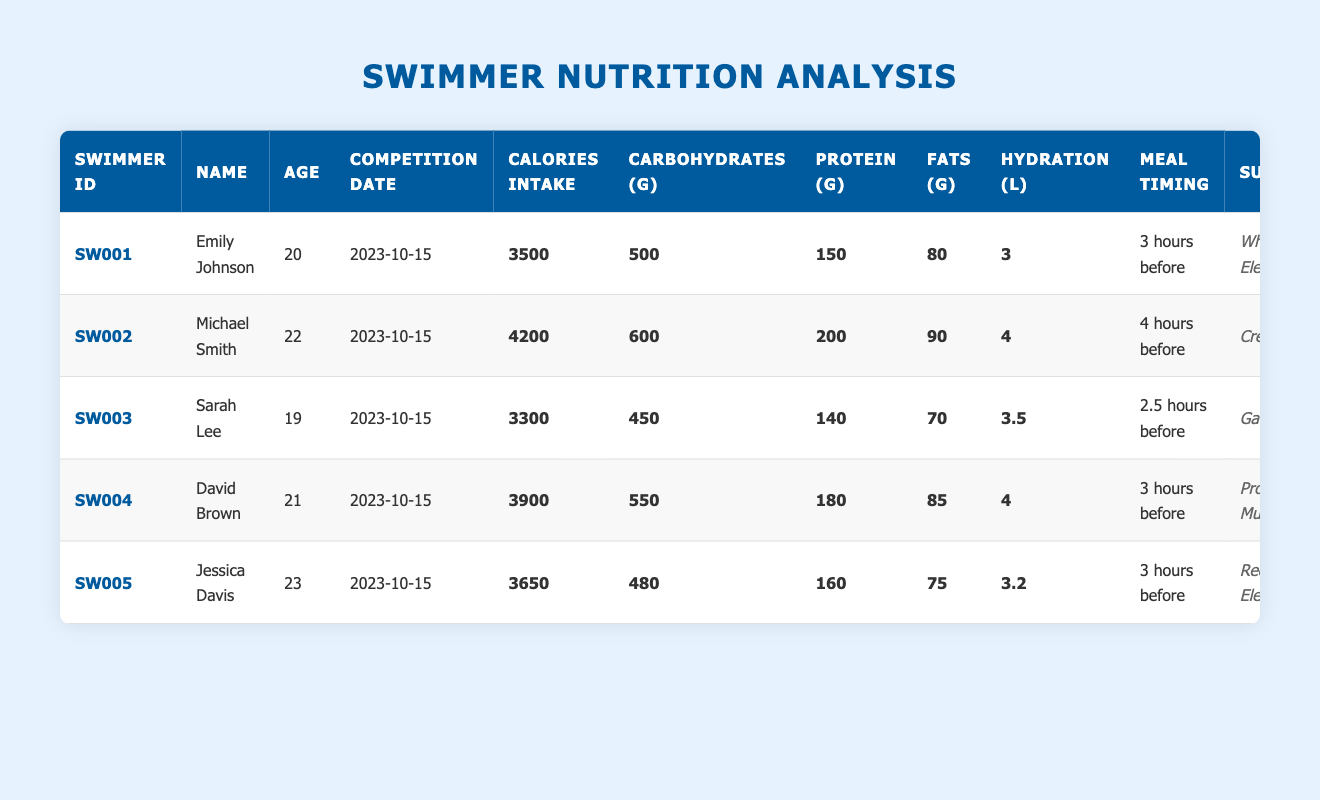What is the calorie intake of Michael Smith? To find this, look for Michael Smith's entry in the table, then check the "Calories Intake" column next to his name. His calorie intake is listed as 4200.
Answer: 4200 Who had the highest fat intake and what was the amount? Reviewing the table, compare the values in the "Fats (g)" column. Michael Smith has 90g, which is the highest compared to the other swimmers.
Answer: Michael Smith, 90g What is the average protein intake of the swimmers? First, sum the protein values: (150 + 200 + 140 + 180 + 160) = 830. There are 5 swimmers, so divide 830 by 5 to get the average: 830/5 = 166.
Answer: 166 Did Jessica Davis consume more carbohydrates than David Brown? Look at the "Carbohydrates (g)" column for both swimmers. Jessica Davis has 480g and David Brown has 550g. Since 480g is less than 550g, the answer is no.
Answer: No What percentage of their total calorie intake comes from protein for Emily Johnson? First, find the amount of protein intake which is 150g. Each gram of protein contains 4 calories, so 150g equals 150 * 4 = 600 calories from protein. Now, divide the protein calories by the total calorie intake: (600/3500) * 100 = 17.14%.
Answer: 17.14% Which swimmer had the least hydration and how much was it? Check the "Hydration (l)" column for all swimmers. Sarah Lee has the least with 3.5 liters.
Answer: Sarah Lee, 3.5 liters What is the total fat intake of all swimmers combined? Add the values for each swimmer from the "Fats (g)" column: (80 + 90 + 70 + 85 + 75) = 400. The total fat intake is 400g.
Answer: 400 Is the meal timing for Sarah Lee shorter than that of Emily Johnson? Compare their meal timings: Sarah Lee ate 2.5 hours before and Emily Johnson 3 hours. Since 2.5 hours is less than 3 hours, the answer is yes.
Answer: Yes What is the median calorie intake of the swimmers? First, list the calorie intakes: 3500, 4200, 3300, 3900, 3650. Arrange them in order: 3300, 3500, 3650, 3900, 4200. The median is the middle value, which is 3650.
Answer: 3650 